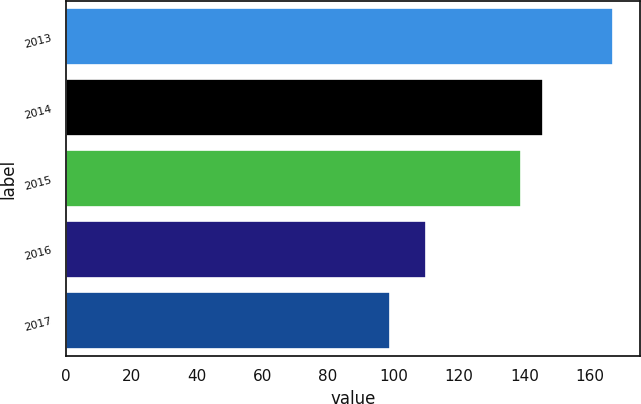Convert chart. <chart><loc_0><loc_0><loc_500><loc_500><bar_chart><fcel>2013<fcel>2014<fcel>2015<fcel>2016<fcel>2017<nl><fcel>167<fcel>145.8<fcel>139<fcel>110<fcel>99<nl></chart> 